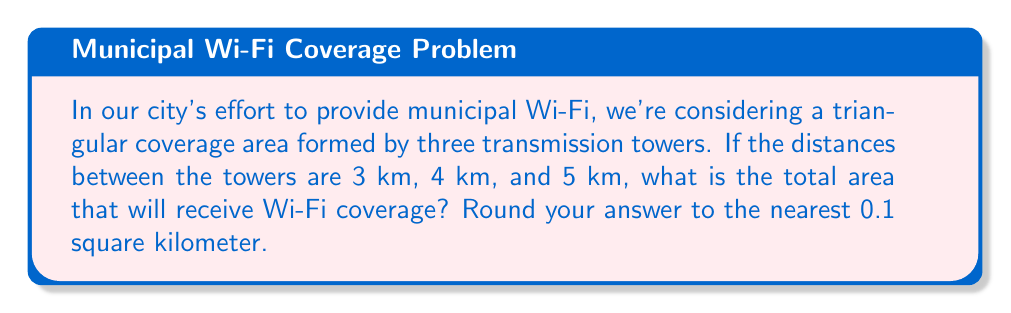Provide a solution to this math problem. Let's approach this step-by-step using Heron's formula:

1) First, we identify that we have a triangle with sides 3 km, 4 km, and 5 km.

2) Heron's formula states that the area $A$ of a triangle with sides $a$, $b$, and $c$ is:

   $$A = \sqrt{s(s-a)(s-b)(s-c)}$$

   where $s$ is the semi-perimeter: $s = \frac{a+b+c}{2}$

3) Let's calculate $s$:
   $$s = \frac{3+4+5}{2} = \frac{12}{2} = 6$$

4) Now we can substitute into Heron's formula:

   $$A = \sqrt{6(6-3)(6-4)(6-5)}$$
   $$A = \sqrt{6 \cdot 3 \cdot 2 \cdot 1}$$
   $$A = \sqrt{36}$$
   $$A = 6$$

5) Therefore, the area is 6 square kilometers.

6) Rounding to the nearest 0.1 square kilometer, our answer remains 6.0 sq km.

This calculation provides a more precise estimate of Wi-Fi coverage than social media discussions might suggest, demonstrating the importance of thorough analysis in policy decisions.
Answer: 6.0 sq km 